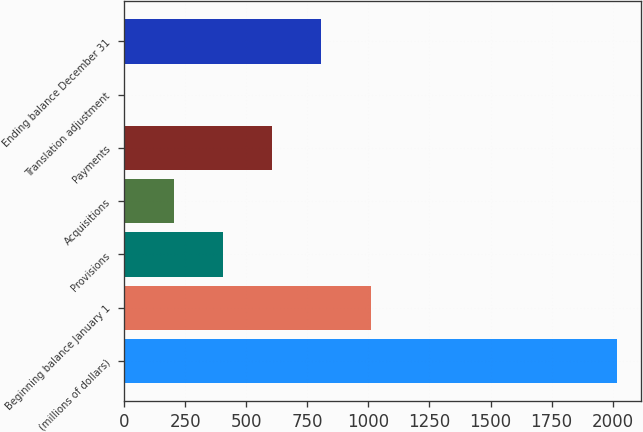Convert chart. <chart><loc_0><loc_0><loc_500><loc_500><bar_chart><fcel>(millions of dollars)<fcel>Beginning balance January 1<fcel>Provisions<fcel>Acquisitions<fcel>Payments<fcel>Translation adjustment<fcel>Ending balance December 31<nl><fcel>2016<fcel>1009.25<fcel>405.2<fcel>203.85<fcel>606.55<fcel>2.5<fcel>807.9<nl></chart> 